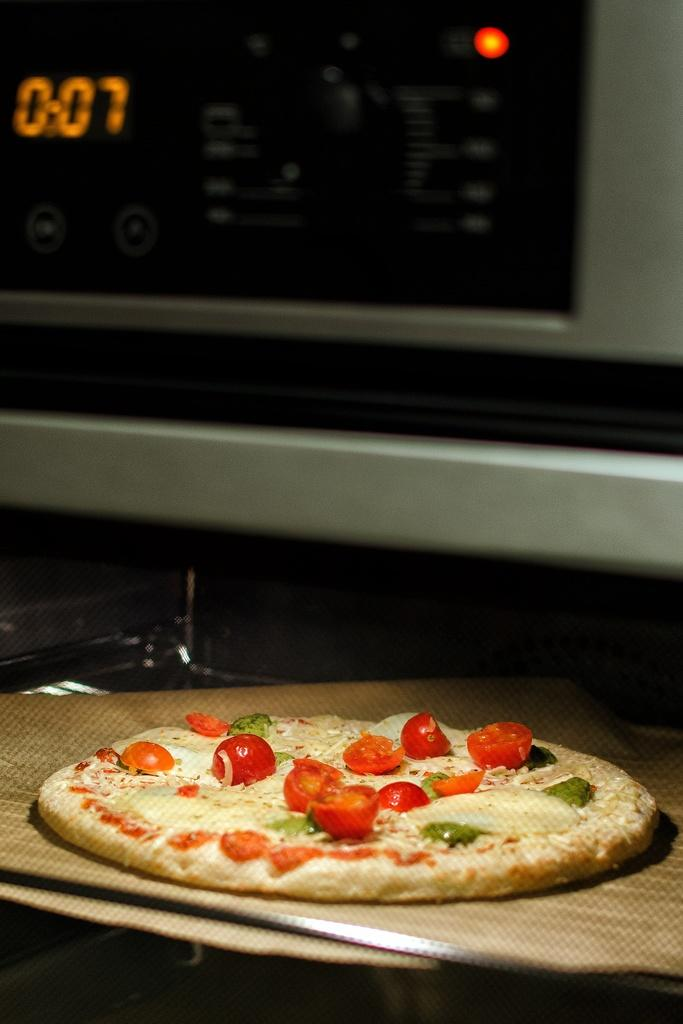<image>
Render a clear and concise summary of the photo. An uncooked pizza in an over with 7 minutes on the timer. 